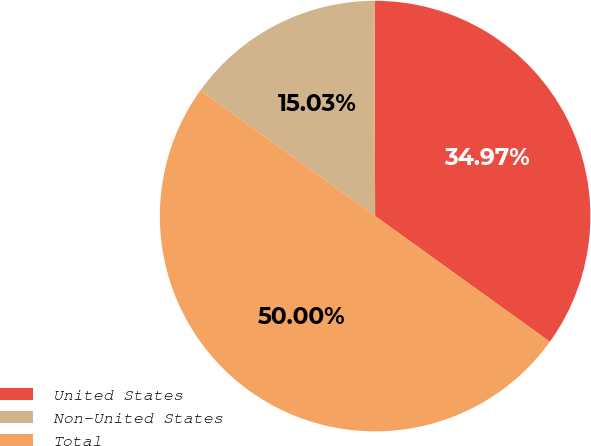Convert chart to OTSL. <chart><loc_0><loc_0><loc_500><loc_500><pie_chart><fcel>United States<fcel>Non-United States<fcel>Total<nl><fcel>34.97%<fcel>15.03%<fcel>50.0%<nl></chart> 